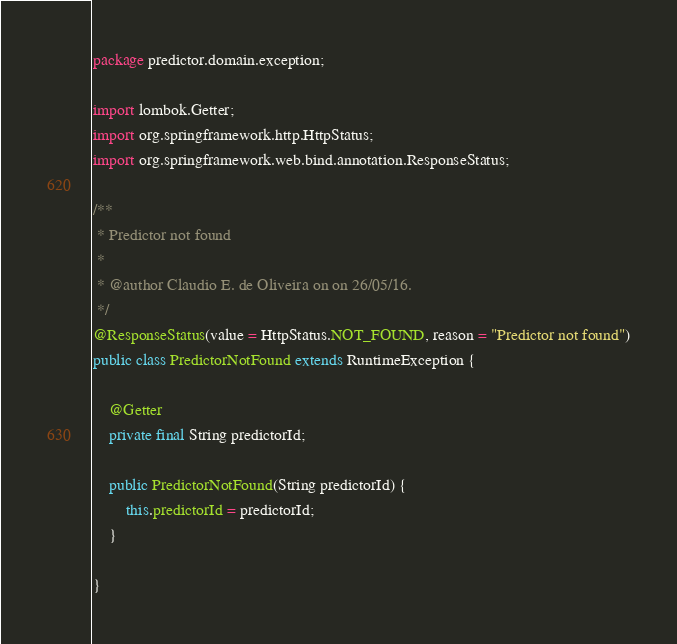Convert code to text. <code><loc_0><loc_0><loc_500><loc_500><_Java_>package predictor.domain.exception;

import lombok.Getter;
import org.springframework.http.HttpStatus;
import org.springframework.web.bind.annotation.ResponseStatus;

/**
 * Predictor not found
 *
 * @author Claudio E. de Oliveira on on 26/05/16.
 */
@ResponseStatus(value = HttpStatus.NOT_FOUND, reason = "Predictor not found")
public class PredictorNotFound extends RuntimeException {

    @Getter
    private final String predictorId;

    public PredictorNotFound(String predictorId) {
        this.predictorId = predictorId;
    }

}
</code> 